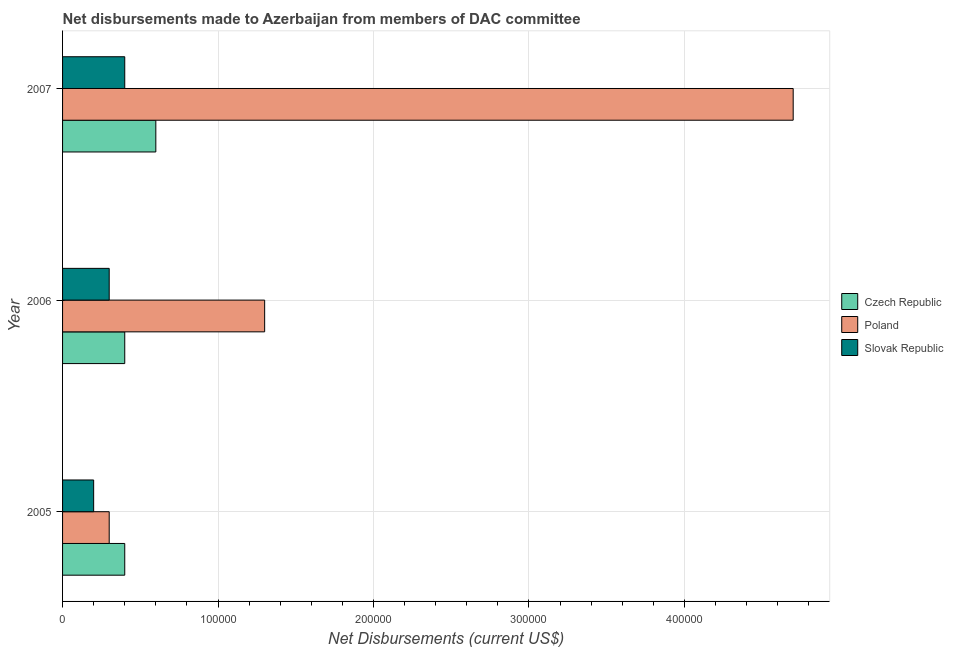How many different coloured bars are there?
Your response must be concise. 3. How many groups of bars are there?
Your answer should be very brief. 3. How many bars are there on the 3rd tick from the top?
Make the answer very short. 3. How many bars are there on the 1st tick from the bottom?
Offer a very short reply. 3. What is the label of the 3rd group of bars from the top?
Your answer should be very brief. 2005. In how many cases, is the number of bars for a given year not equal to the number of legend labels?
Your response must be concise. 0. What is the net disbursements made by poland in 2007?
Provide a succinct answer. 4.70e+05. Across all years, what is the maximum net disbursements made by czech republic?
Offer a very short reply. 6.00e+04. Across all years, what is the minimum net disbursements made by slovak republic?
Keep it short and to the point. 2.00e+04. In which year was the net disbursements made by czech republic maximum?
Give a very brief answer. 2007. What is the total net disbursements made by czech republic in the graph?
Provide a succinct answer. 1.40e+05. What is the difference between the net disbursements made by poland in 2005 and that in 2007?
Offer a terse response. -4.40e+05. What is the difference between the net disbursements made by czech republic in 2007 and the net disbursements made by slovak republic in 2005?
Ensure brevity in your answer.  4.00e+04. What is the average net disbursements made by slovak republic per year?
Keep it short and to the point. 3.00e+04. In the year 2006, what is the difference between the net disbursements made by poland and net disbursements made by czech republic?
Give a very brief answer. 9.00e+04. In how many years, is the net disbursements made by poland greater than 300000 US$?
Ensure brevity in your answer.  1. What is the ratio of the net disbursements made by czech republic in 2005 to that in 2006?
Keep it short and to the point. 1. What is the difference between the highest and the second highest net disbursements made by czech republic?
Your answer should be compact. 2.00e+04. What is the difference between the highest and the lowest net disbursements made by slovak republic?
Offer a very short reply. 2.00e+04. What does the 3rd bar from the top in 2006 represents?
Offer a terse response. Czech Republic. What does the 3rd bar from the bottom in 2005 represents?
Give a very brief answer. Slovak Republic. Is it the case that in every year, the sum of the net disbursements made by czech republic and net disbursements made by poland is greater than the net disbursements made by slovak republic?
Your answer should be very brief. Yes. How many bars are there?
Ensure brevity in your answer.  9. How many years are there in the graph?
Provide a succinct answer. 3. Does the graph contain grids?
Ensure brevity in your answer.  Yes. How are the legend labels stacked?
Offer a very short reply. Vertical. What is the title of the graph?
Ensure brevity in your answer.  Net disbursements made to Azerbaijan from members of DAC committee. Does "Agriculture" appear as one of the legend labels in the graph?
Make the answer very short. No. What is the label or title of the X-axis?
Your answer should be very brief. Net Disbursements (current US$). What is the Net Disbursements (current US$) in Poland in 2005?
Give a very brief answer. 3.00e+04. What is the Net Disbursements (current US$) in Slovak Republic in 2005?
Offer a very short reply. 2.00e+04. What is the Net Disbursements (current US$) of Poland in 2007?
Provide a succinct answer. 4.70e+05. Across all years, what is the maximum Net Disbursements (current US$) in Slovak Republic?
Your response must be concise. 4.00e+04. Across all years, what is the minimum Net Disbursements (current US$) in Poland?
Offer a very short reply. 3.00e+04. Across all years, what is the minimum Net Disbursements (current US$) in Slovak Republic?
Provide a succinct answer. 2.00e+04. What is the total Net Disbursements (current US$) in Poland in the graph?
Provide a succinct answer. 6.30e+05. What is the total Net Disbursements (current US$) in Slovak Republic in the graph?
Keep it short and to the point. 9.00e+04. What is the difference between the Net Disbursements (current US$) in Slovak Republic in 2005 and that in 2006?
Keep it short and to the point. -10000. What is the difference between the Net Disbursements (current US$) in Poland in 2005 and that in 2007?
Give a very brief answer. -4.40e+05. What is the difference between the Net Disbursements (current US$) in Czech Republic in 2006 and that in 2007?
Ensure brevity in your answer.  -2.00e+04. What is the difference between the Net Disbursements (current US$) in Slovak Republic in 2006 and that in 2007?
Make the answer very short. -10000. What is the difference between the Net Disbursements (current US$) of Czech Republic in 2005 and the Net Disbursements (current US$) of Poland in 2007?
Keep it short and to the point. -4.30e+05. What is the difference between the Net Disbursements (current US$) of Czech Republic in 2005 and the Net Disbursements (current US$) of Slovak Republic in 2007?
Keep it short and to the point. 0. What is the difference between the Net Disbursements (current US$) in Czech Republic in 2006 and the Net Disbursements (current US$) in Poland in 2007?
Your answer should be compact. -4.30e+05. What is the difference between the Net Disbursements (current US$) of Poland in 2006 and the Net Disbursements (current US$) of Slovak Republic in 2007?
Your response must be concise. 9.00e+04. What is the average Net Disbursements (current US$) in Czech Republic per year?
Make the answer very short. 4.67e+04. What is the average Net Disbursements (current US$) in Slovak Republic per year?
Your response must be concise. 3.00e+04. In the year 2005, what is the difference between the Net Disbursements (current US$) of Czech Republic and Net Disbursements (current US$) of Poland?
Give a very brief answer. 10000. In the year 2006, what is the difference between the Net Disbursements (current US$) of Czech Republic and Net Disbursements (current US$) of Slovak Republic?
Keep it short and to the point. 10000. In the year 2007, what is the difference between the Net Disbursements (current US$) in Czech Republic and Net Disbursements (current US$) in Poland?
Your answer should be very brief. -4.10e+05. In the year 2007, what is the difference between the Net Disbursements (current US$) of Czech Republic and Net Disbursements (current US$) of Slovak Republic?
Your answer should be very brief. 2.00e+04. In the year 2007, what is the difference between the Net Disbursements (current US$) of Poland and Net Disbursements (current US$) of Slovak Republic?
Your answer should be compact. 4.30e+05. What is the ratio of the Net Disbursements (current US$) in Czech Republic in 2005 to that in 2006?
Keep it short and to the point. 1. What is the ratio of the Net Disbursements (current US$) in Poland in 2005 to that in 2006?
Your response must be concise. 0.23. What is the ratio of the Net Disbursements (current US$) in Poland in 2005 to that in 2007?
Offer a very short reply. 0.06. What is the ratio of the Net Disbursements (current US$) of Slovak Republic in 2005 to that in 2007?
Provide a short and direct response. 0.5. What is the ratio of the Net Disbursements (current US$) of Poland in 2006 to that in 2007?
Provide a succinct answer. 0.28. What is the ratio of the Net Disbursements (current US$) of Slovak Republic in 2006 to that in 2007?
Offer a very short reply. 0.75. What is the difference between the highest and the second highest Net Disbursements (current US$) in Czech Republic?
Your answer should be very brief. 2.00e+04. What is the difference between the highest and the second highest Net Disbursements (current US$) of Slovak Republic?
Ensure brevity in your answer.  10000. What is the difference between the highest and the lowest Net Disbursements (current US$) in Czech Republic?
Offer a very short reply. 2.00e+04. What is the difference between the highest and the lowest Net Disbursements (current US$) in Slovak Republic?
Provide a short and direct response. 2.00e+04. 